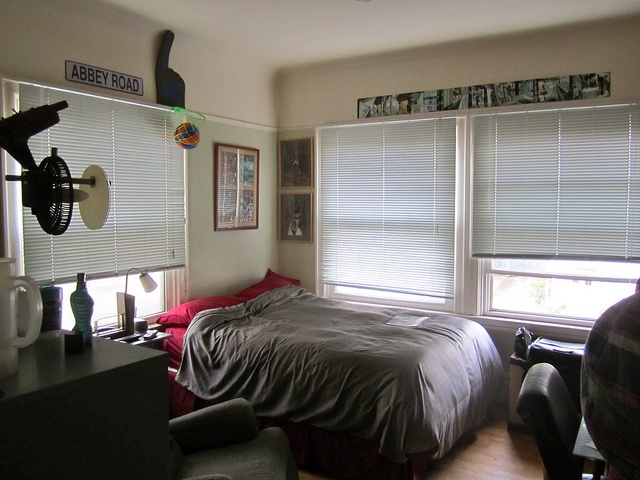Describe the objects in this image and their specific colors. I can see bed in gray, black, darkgray, and maroon tones, chair in gray, black, and darkgray tones, bottle in gray and black tones, and sports ball in gray, maroon, black, and tan tones in this image. 